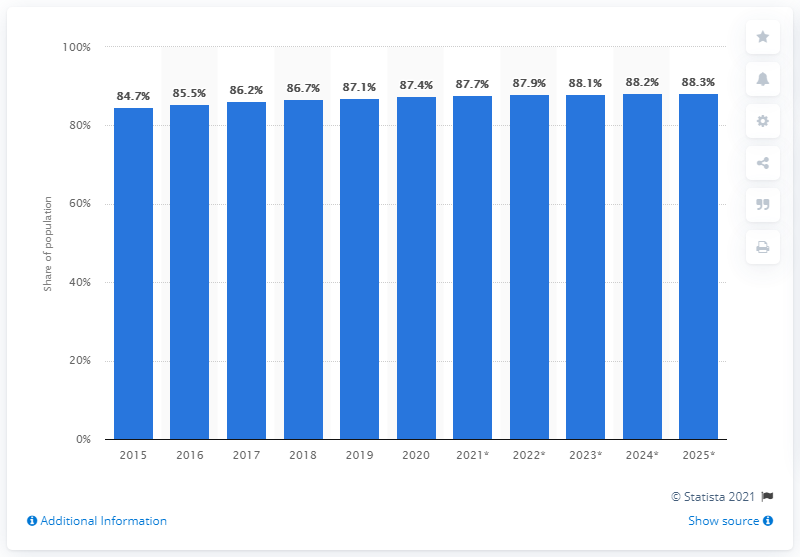Draw attention to some important aspects in this diagram. In 2020, 87.4% of the Canadian population accessed the internet. 